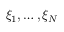<formula> <loc_0><loc_0><loc_500><loc_500>\xi _ { 1 } , \dots , \xi _ { N }</formula> 